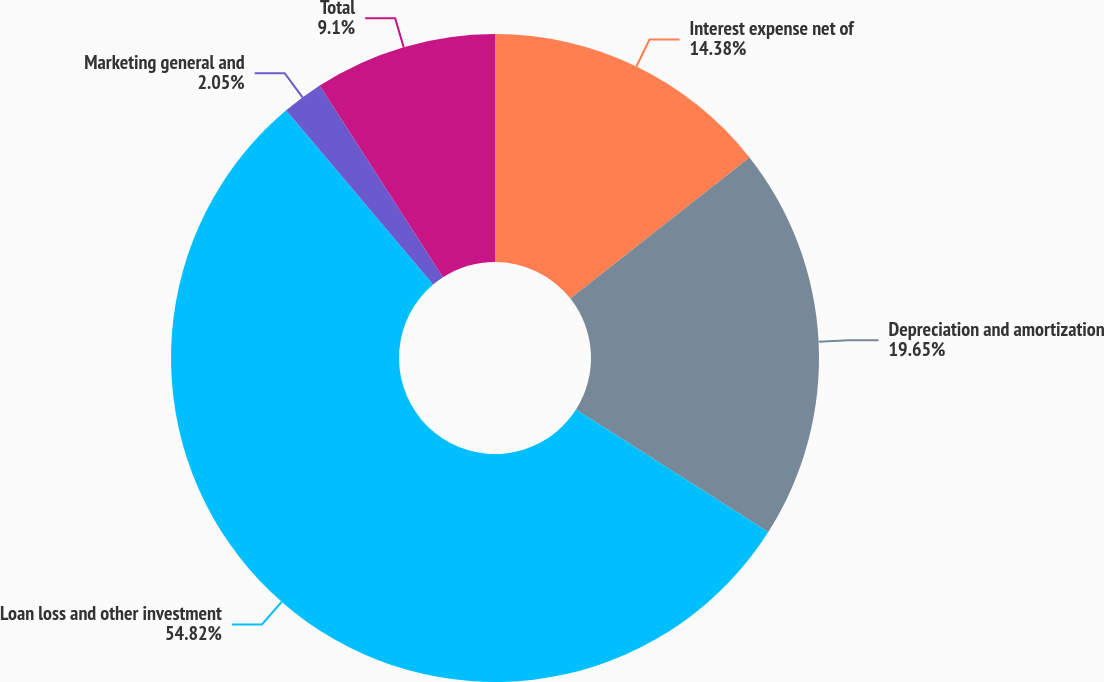Convert chart to OTSL. <chart><loc_0><loc_0><loc_500><loc_500><pie_chart><fcel>Interest expense net of<fcel>Depreciation and amortization<fcel>Loan loss and other investment<fcel>Marketing general and<fcel>Total<nl><fcel>14.38%<fcel>19.65%<fcel>54.83%<fcel>2.05%<fcel>9.1%<nl></chart> 